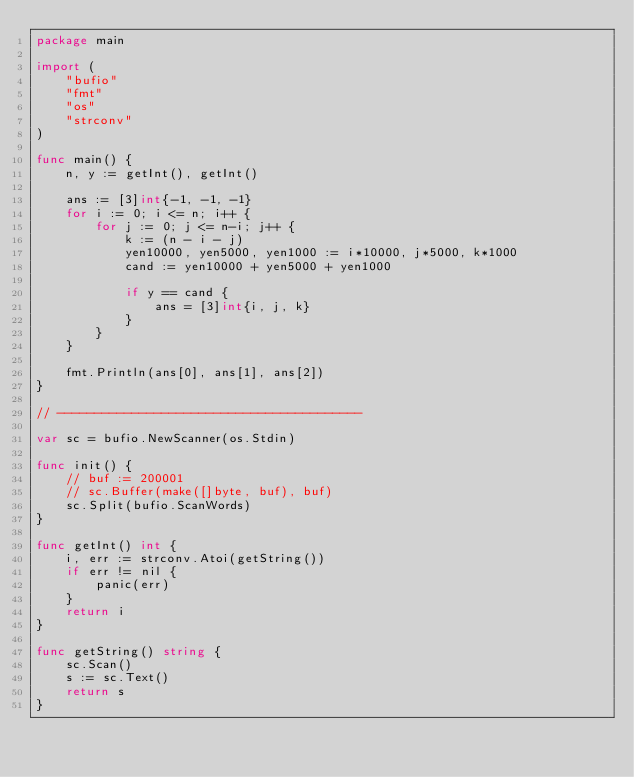<code> <loc_0><loc_0><loc_500><loc_500><_Go_>package main

import (
	"bufio"
	"fmt"
	"os"
	"strconv"
)

func main() {
	n, y := getInt(), getInt()

	ans := [3]int{-1, -1, -1}
	for i := 0; i <= n; i++ {
		for j := 0; j <= n-i; j++ {
			k := (n - i - j)
			yen10000, yen5000, yen1000 := i*10000, j*5000, k*1000
			cand := yen10000 + yen5000 + yen1000

			if y == cand {
				ans = [3]int{i, j, k}
			}
		}
	}

	fmt.Println(ans[0], ans[1], ans[2])
}

// -----------------------------------------

var sc = bufio.NewScanner(os.Stdin)

func init() {
	// buf := 200001
	// sc.Buffer(make([]byte, buf), buf)
	sc.Split(bufio.ScanWords)
}

func getInt() int {
	i, err := strconv.Atoi(getString())
	if err != nil {
		panic(err)
	}
	return i
}

func getString() string {
	sc.Scan()
	s := sc.Text()
	return s
}
</code> 